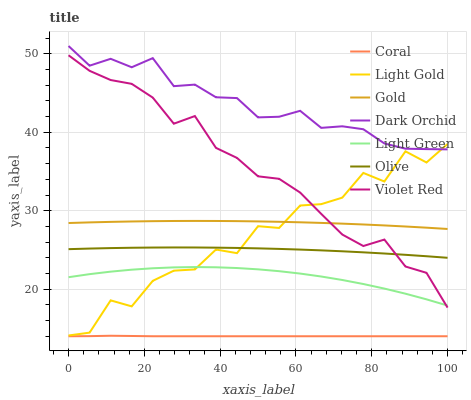Does Coral have the minimum area under the curve?
Answer yes or no. Yes. Does Dark Orchid have the maximum area under the curve?
Answer yes or no. Yes. Does Gold have the minimum area under the curve?
Answer yes or no. No. Does Gold have the maximum area under the curve?
Answer yes or no. No. Is Coral the smoothest?
Answer yes or no. Yes. Is Light Gold the roughest?
Answer yes or no. Yes. Is Gold the smoothest?
Answer yes or no. No. Is Gold the roughest?
Answer yes or no. No. Does Coral have the lowest value?
Answer yes or no. Yes. Does Gold have the lowest value?
Answer yes or no. No. Does Dark Orchid have the highest value?
Answer yes or no. Yes. Does Gold have the highest value?
Answer yes or no. No. Is Olive less than Gold?
Answer yes or no. Yes. Is Dark Orchid greater than Gold?
Answer yes or no. Yes. Does Violet Red intersect Light Gold?
Answer yes or no. Yes. Is Violet Red less than Light Gold?
Answer yes or no. No. Is Violet Red greater than Light Gold?
Answer yes or no. No. Does Olive intersect Gold?
Answer yes or no. No. 